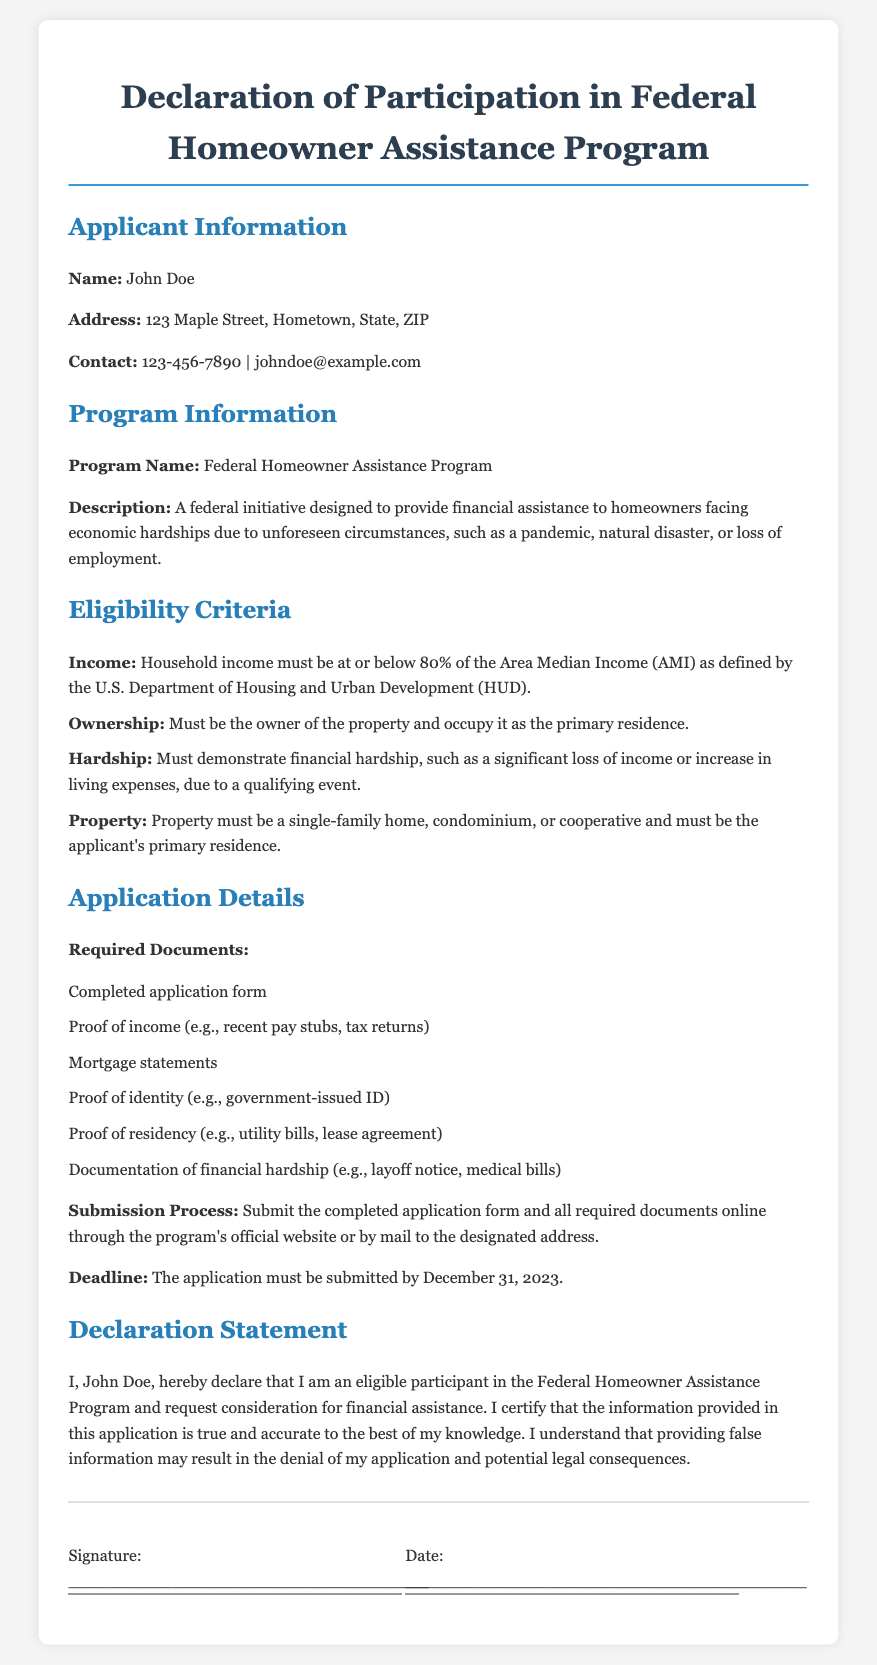What is the applicant's name? The applicant's name is explicitly stated in the document.
Answer: John Doe What is the program's description? The description details the purpose of the program helping homeowners in financial hardship.
Answer: A federal initiative designed to provide financial assistance to homeowners facing economic hardships due to unforeseen circumstances, such as a pandemic, natural disaster, or loss of employment What is the deadline for application submission? The deadline is mentioned clearly in the application details section.
Answer: December 31, 2023 What percentage of Area Median Income must the household income be below? This information is specified as part of the eligibility criteria.
Answer: 80% What type of property is eligible for the program? The eligibility section specifies the property type required for assistance.
Answer: single-family home, condominium, or cooperative What is a required document for the application? The application details list mandatory documents for submission.
Answer: Completed application form What does the applicant certify in the declaration statement? The declaration statement outlines the applicant's official certification.
Answer: The information provided in this application is true and accurate to the best of my knowledge What is one example of documentation of financial hardship? The application details give an example of what qualifies as financial hardship documentation.
Answer: layoff notice What is the applicant's contact number? The applicant's contact information is presented clearly in the document.
Answer: 123-456-7890 